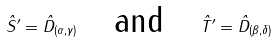Convert formula to latex. <formula><loc_0><loc_0><loc_500><loc_500>\hat { S } ^ { \prime } = \hat { D } _ { ( \alpha , \gamma ) } \quad \text {and} \quad \hat { T } ^ { \prime } = \hat { D } _ { ( \beta , \delta ) }</formula> 